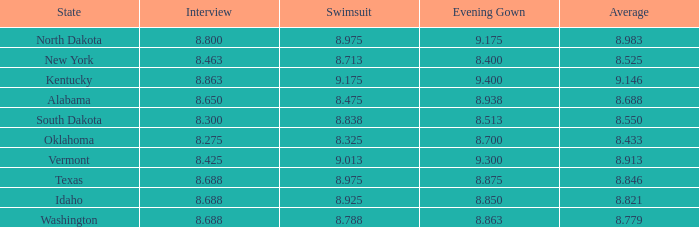What is the maximum swimsuit score for a participant with an evening dress greater than None. 